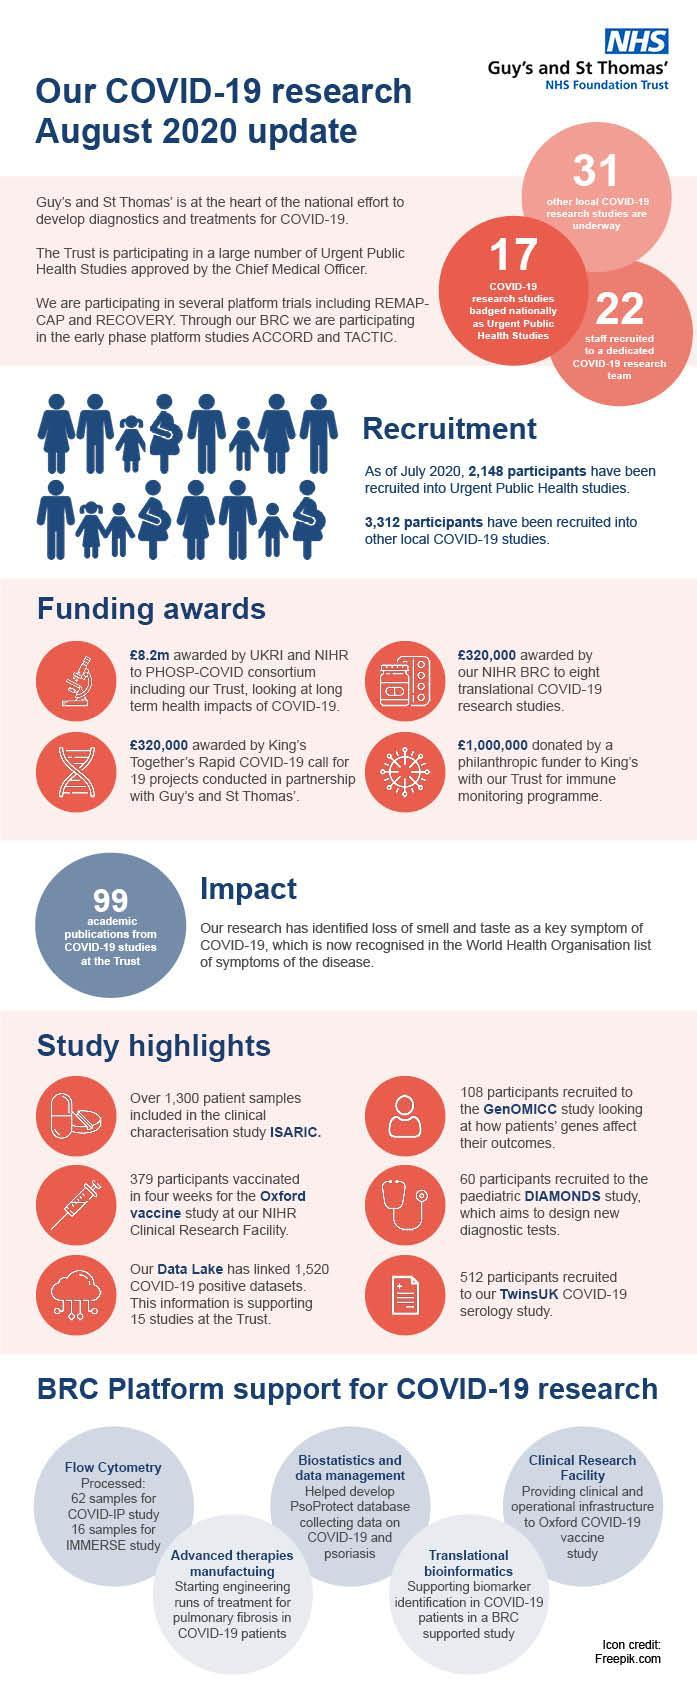how many publications from COVID-19 studies at the Trust
Answer the question with a short phrase. 99 Which platform has supported Oxford COVID-19 vaccine study Clinical Research Facility How much has been awarded to by NIHR BRC and King's 640000 how many other local COVID-19 studies are underway 31 Which platform helped in collecting data on COVID-19 and psoriasis Biostatistics and data management What is the total participants recruited to GenOMICC and TwinsUK 620 